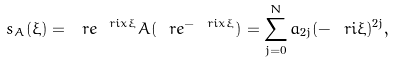<formula> <loc_0><loc_0><loc_500><loc_500>s _ { A } ( \xi ) = \ r e ^ { \ r i x \xi } A ( \ r e ^ { - \ r i x \xi } ) = \sum _ { j = 0 } ^ { N } a _ { 2 j } ( - \ r i \xi ) ^ { 2 j } ,</formula> 